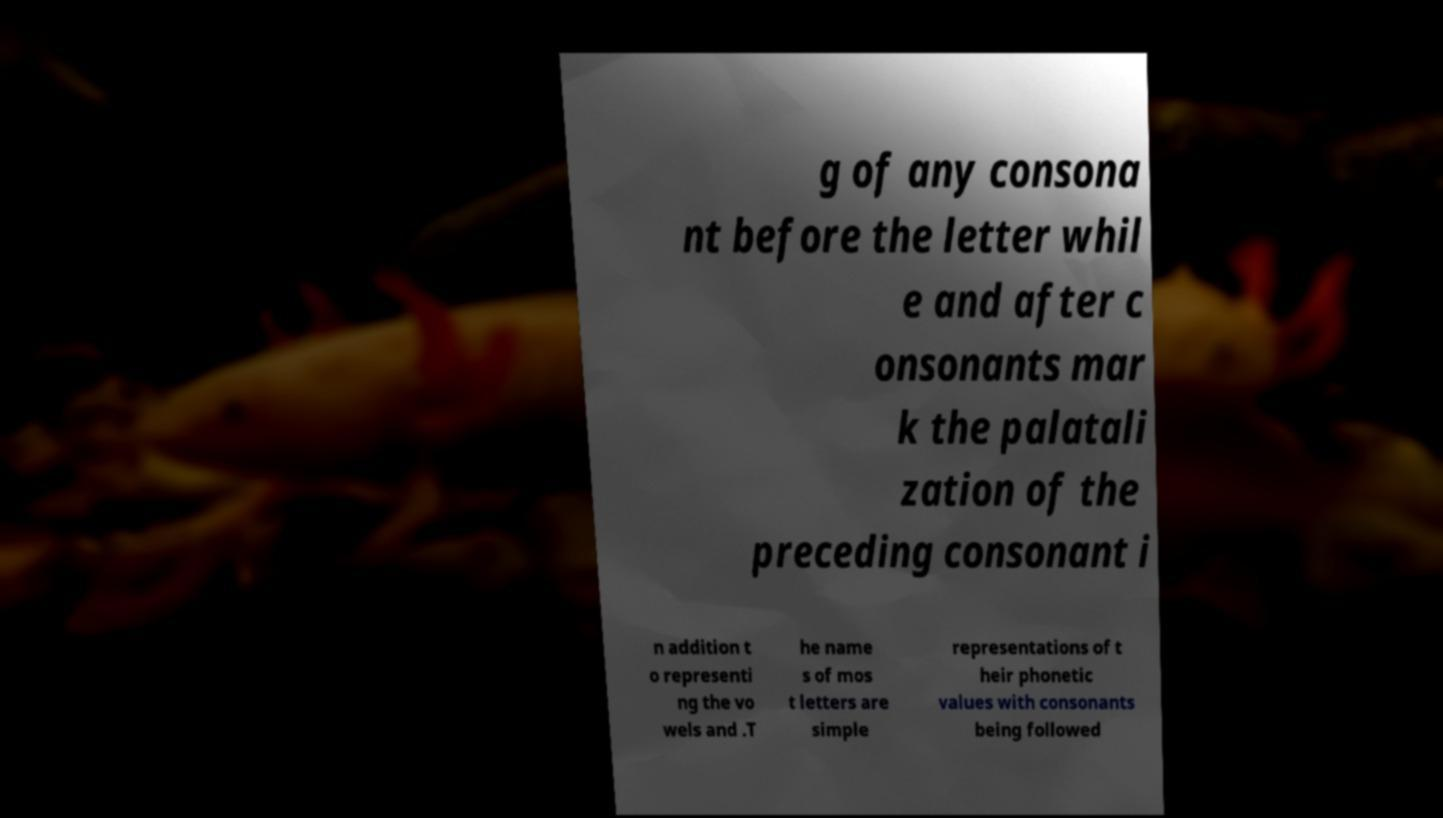Could you extract and type out the text from this image? g of any consona nt before the letter whil e and after c onsonants mar k the palatali zation of the preceding consonant i n addition t o representi ng the vo wels and .T he name s of mos t letters are simple representations of t heir phonetic values with consonants being followed 